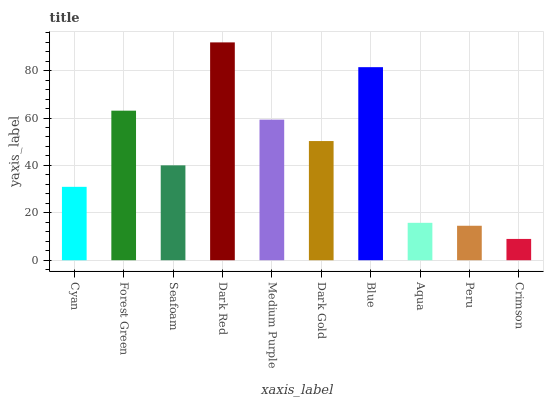Is Crimson the minimum?
Answer yes or no. Yes. Is Dark Red the maximum?
Answer yes or no. Yes. Is Forest Green the minimum?
Answer yes or no. No. Is Forest Green the maximum?
Answer yes or no. No. Is Forest Green greater than Cyan?
Answer yes or no. Yes. Is Cyan less than Forest Green?
Answer yes or no. Yes. Is Cyan greater than Forest Green?
Answer yes or no. No. Is Forest Green less than Cyan?
Answer yes or no. No. Is Dark Gold the high median?
Answer yes or no. Yes. Is Seafoam the low median?
Answer yes or no. Yes. Is Dark Red the high median?
Answer yes or no. No. Is Peru the low median?
Answer yes or no. No. 